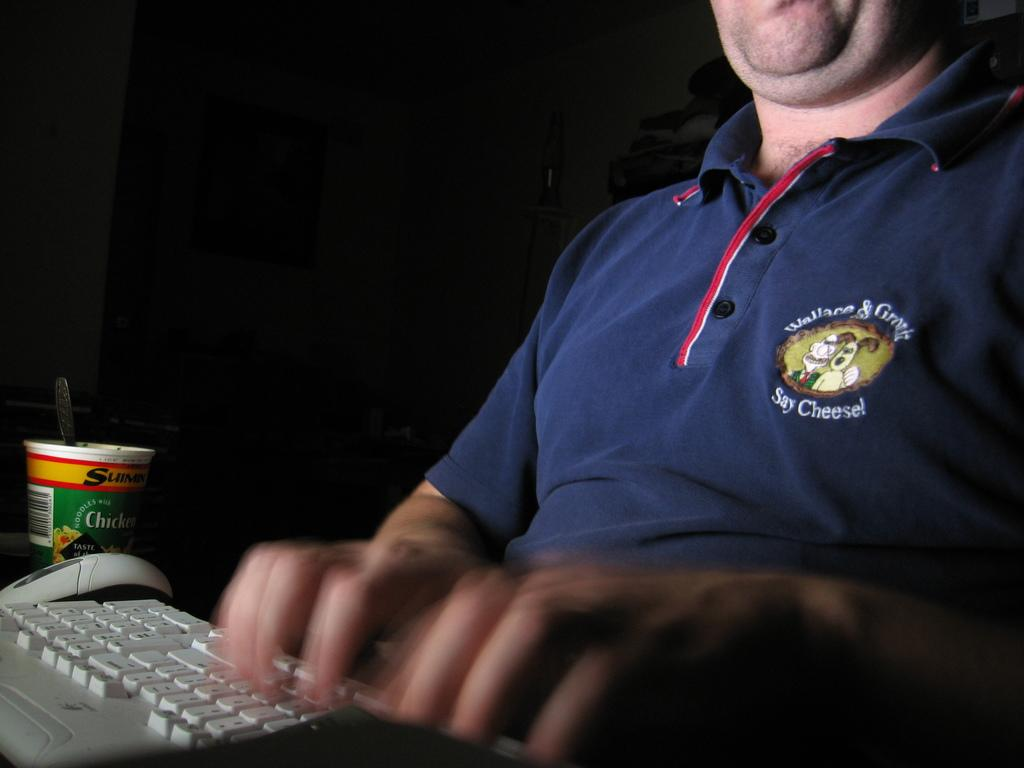What is the person in the image doing? The person is sitting and typing on a keyboard. What is located on the left side of the image? There is a mouse and a cup with a spoon on the left side of the image. What can be seen in the background of the image? There are objects visible in the background of the image. What type of news is the person reading from the pipe in the image? There is no pipe or news present in the image. How does the person use the toothbrush while typing in the image? There is no toothbrush visible in the image. 